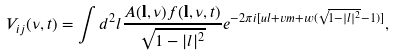Convert formula to latex. <formula><loc_0><loc_0><loc_500><loc_500>V _ { i j } ( \nu , t ) = \int d ^ { 2 } l \frac { A ( { \mathbf l } , \nu ) f ( { \mathbf l } , \nu , t ) } { \sqrt { 1 - | l | ^ { 2 } } } e ^ { - 2 \pi i [ u l + v m + w ( \sqrt { 1 - | l | ^ { 2 } } - 1 ) ] } ,</formula> 